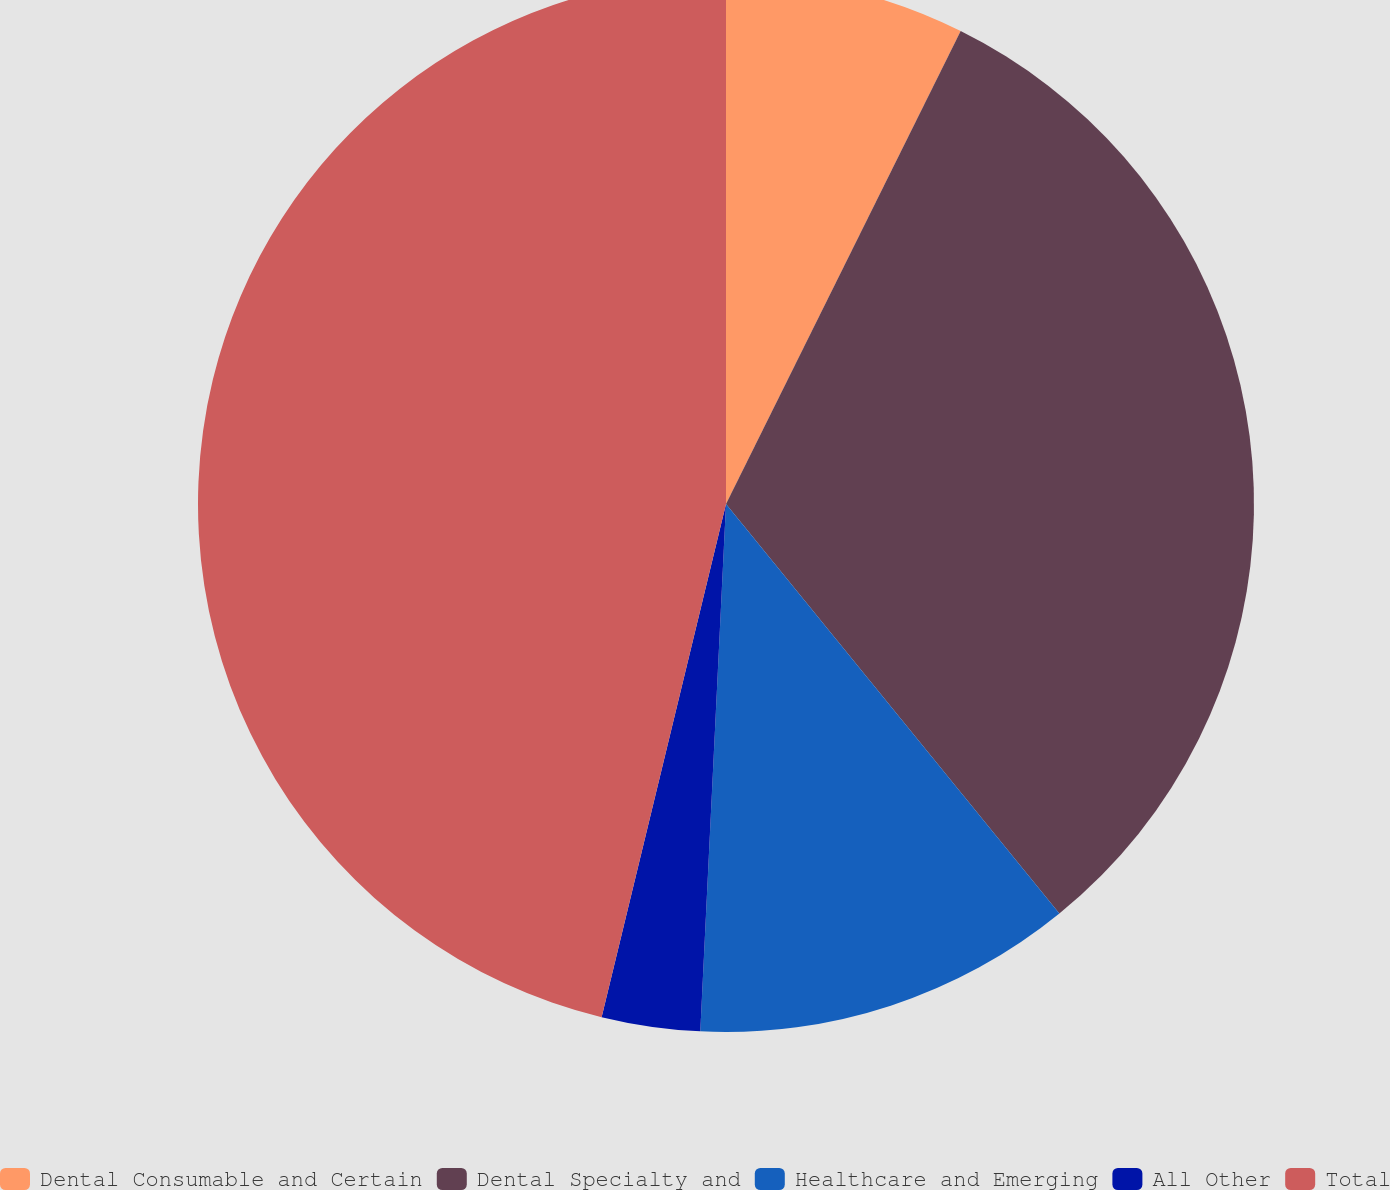Convert chart to OTSL. <chart><loc_0><loc_0><loc_500><loc_500><pie_chart><fcel>Dental Consumable and Certain<fcel>Dental Specialty and<fcel>Healthcare and Emerging<fcel>All Other<fcel>Total<nl><fcel>7.33%<fcel>31.79%<fcel>11.65%<fcel>3.01%<fcel>46.21%<nl></chart> 